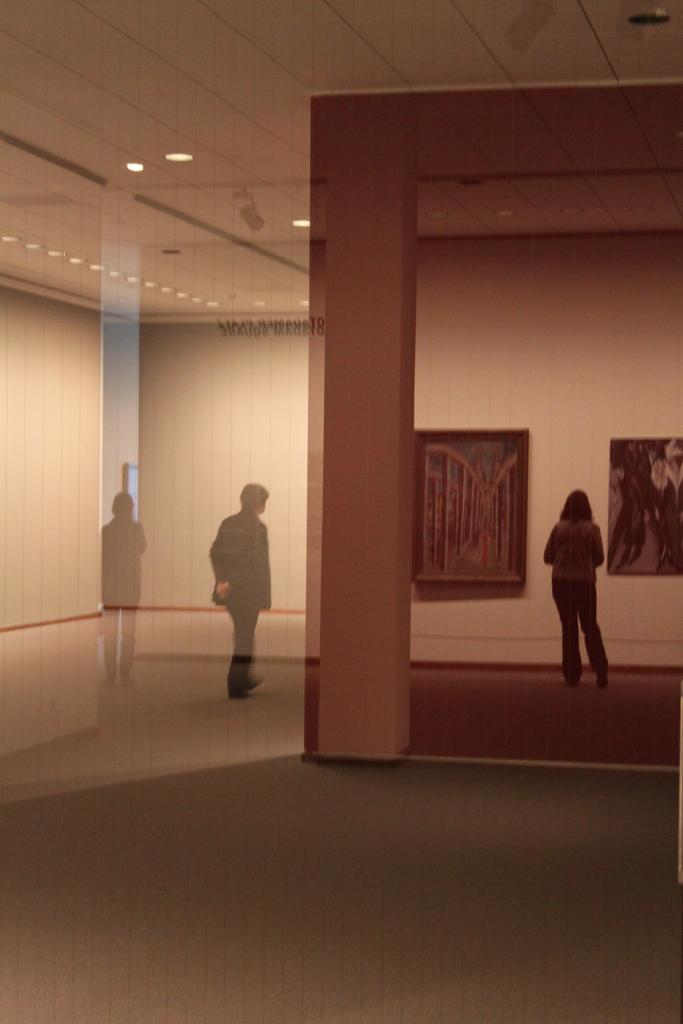What type of location is depicted in the image? The image shows an inside view of a building. How many people are present in the image? There are three people standing in the image. What structural elements can be seen in the image? The image contains walls, frames, and a ceiling. What type of illumination is present in the image? Lights are visible in the image. Are there any objects present in the image? Yes, there are objects present in the image. Can you tell me how many goldfish are swimming in the frames in the image? There are no goldfish present in the image; the frames contain objects other than goldfish. What type of sport is being played by the people in the image? The image does not show any sport being played; it only depicts three people standing in a building. 